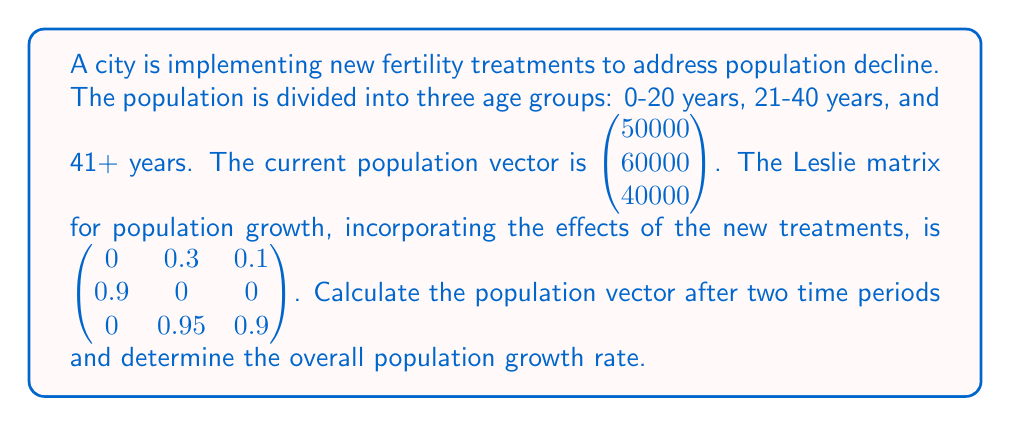Help me with this question. 1. To calculate the population vector after two time periods, we need to multiply the Leslie matrix by itself and then multiply the result by the initial population vector.

   Let $A = \begin{pmatrix} 0 & 0.3 & 0.1 \\ 0.9 & 0 & 0 \\ 0 & 0.95 & 0.9 \end{pmatrix}$ and $v_0 = \begin{pmatrix} 50000 \\ 60000 \\ 40000 \end{pmatrix}$

2. Calculate $A^2$:
   $$A^2 = \begin{pmatrix} 0 & 0.3 & 0.1 \\ 0.9 & 0 & 0 \\ 0 & 0.95 & 0.9 \end{pmatrix} \times \begin{pmatrix} 0 & 0.3 & 0.1 \\ 0.9 & 0 & 0 \\ 0 & 0.95 & 0.9 \end{pmatrix} = \begin{pmatrix} 0.27 & 0.285 & 0.09 \\ 0 & 0.27 & 0.09 \\ 0.855 & 0.855 & 0.81 \end{pmatrix}$$

3. Calculate the population vector after two time periods:
   $$v_2 = A^2 \times v_0 = \begin{pmatrix} 0.27 & 0.285 & 0.09 \\ 0 & 0.27 & 0.09 \\ 0.855 & 0.855 & 0.81 \end{pmatrix} \times \begin{pmatrix} 50000 \\ 60000 \\ 40000 \end{pmatrix} = \begin{pmatrix} 34650 \\ 16200 \\ 106650 \end{pmatrix}$$

4. Calculate the total population after two time periods:
   $34650 + 16200 + 106650 = 157500$

5. Calculate the overall population growth rate:
   Initial total population: $50000 + 60000 + 40000 = 150000$
   Growth rate = $\frac{\text{New Population} - \text{Initial Population}}{\text{Initial Population}} \times 100\%$
   $= \frac{157500 - 150000}{150000} \times 100\% = 5\%$
Answer: 5% 